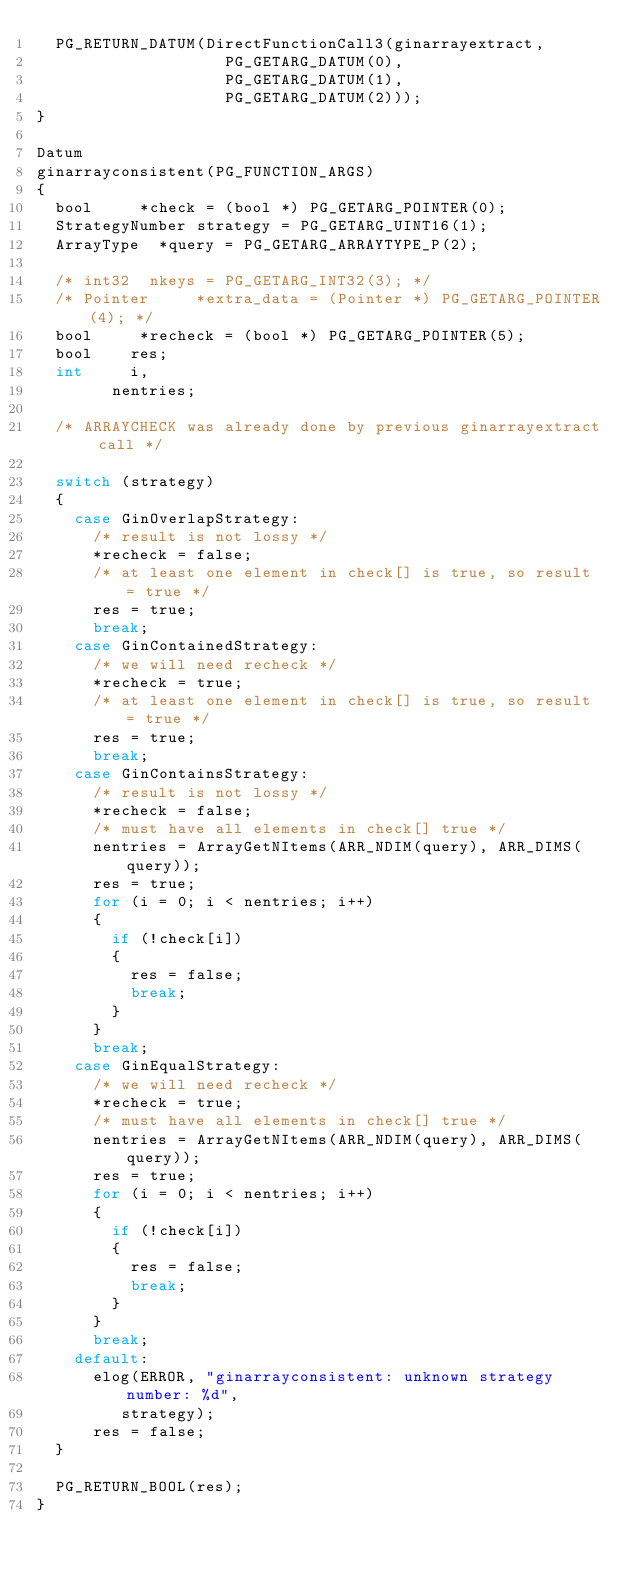Convert code to text. <code><loc_0><loc_0><loc_500><loc_500><_C_>	PG_RETURN_DATUM(DirectFunctionCall3(ginarrayextract,
										PG_GETARG_DATUM(0),
										PG_GETARG_DATUM(1),
										PG_GETARG_DATUM(2)));
}

Datum
ginarrayconsistent(PG_FUNCTION_ARGS)
{
	bool	   *check = (bool *) PG_GETARG_POINTER(0);
	StrategyNumber strategy = PG_GETARG_UINT16(1);
	ArrayType  *query = PG_GETARG_ARRAYTYPE_P(2);

	/* int32	nkeys = PG_GETARG_INT32(3); */
	/* Pointer	   *extra_data = (Pointer *) PG_GETARG_POINTER(4); */
	bool	   *recheck = (bool *) PG_GETARG_POINTER(5);
	bool		res;
	int			i,
				nentries;

	/* ARRAYCHECK was already done by previous ginarrayextract call */

	switch (strategy)
	{
		case GinOverlapStrategy:
			/* result is not lossy */
			*recheck = false;
			/* at least one element in check[] is true, so result = true */
			res = true;
			break;
		case GinContainedStrategy:
			/* we will need recheck */
			*recheck = true;
			/* at least one element in check[] is true, so result = true */
			res = true;
			break;
		case GinContainsStrategy:
			/* result is not lossy */
			*recheck = false;
			/* must have all elements in check[] true */
			nentries = ArrayGetNItems(ARR_NDIM(query), ARR_DIMS(query));
			res = true;
			for (i = 0; i < nentries; i++)
			{
				if (!check[i])
				{
					res = false;
					break;
				}
			}
			break;
		case GinEqualStrategy:
			/* we will need recheck */
			*recheck = true;
			/* must have all elements in check[] true */
			nentries = ArrayGetNItems(ARR_NDIM(query), ARR_DIMS(query));
			res = true;
			for (i = 0; i < nentries; i++)
			{
				if (!check[i])
				{
					res = false;
					break;
				}
			}
			break;
		default:
			elog(ERROR, "ginarrayconsistent: unknown strategy number: %d",
				 strategy);
			res = false;
	}

	PG_RETURN_BOOL(res);
}
</code> 